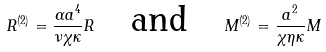Convert formula to latex. <formula><loc_0><loc_0><loc_500><loc_500>R ^ { ( 2 ) } = \frac { \alpha a ^ { 4 } } { \nu \chi \kappa } R \quad \text {and} \quad M ^ { ( 2 ) } = \frac { a ^ { 2 } } { \chi \eta \kappa } M</formula> 